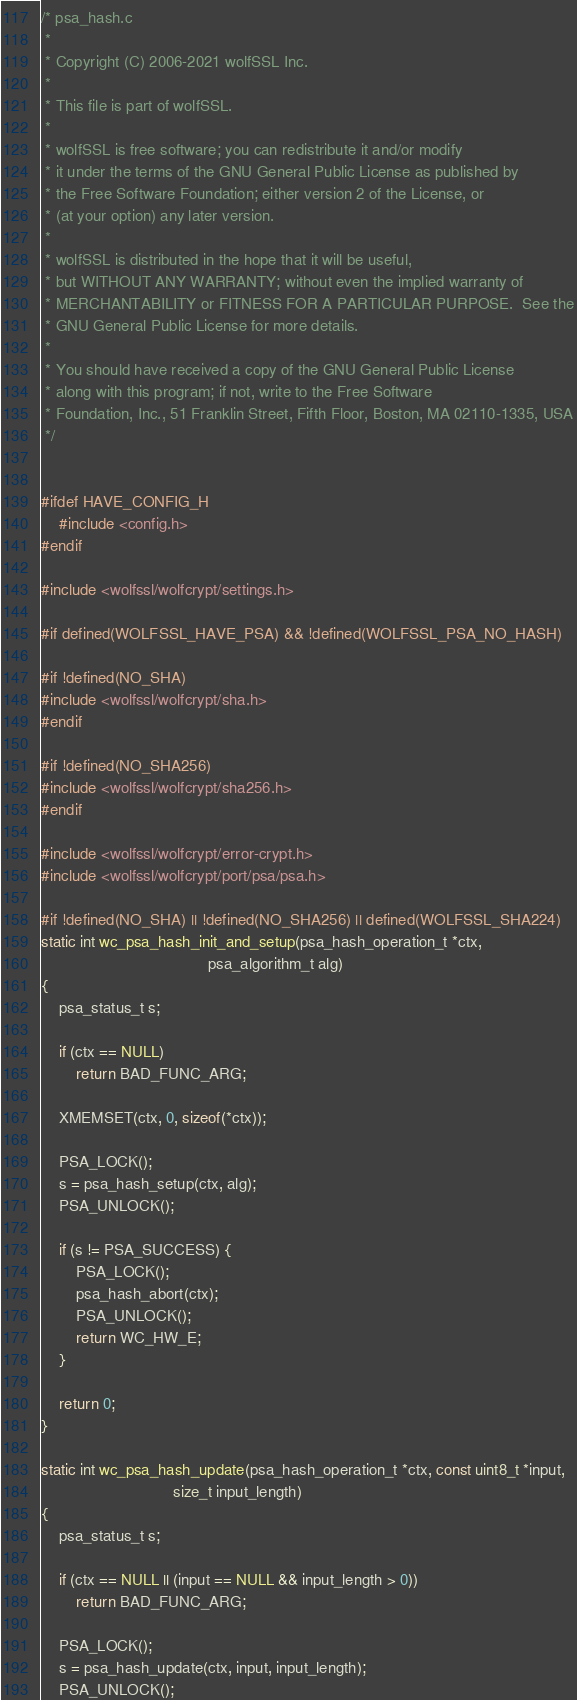Convert code to text. <code><loc_0><loc_0><loc_500><loc_500><_C_>/* psa_hash.c
 *
 * Copyright (C) 2006-2021 wolfSSL Inc.
 *
 * This file is part of wolfSSL.
 *
 * wolfSSL is free software; you can redistribute it and/or modify
 * it under the terms of the GNU General Public License as published by
 * the Free Software Foundation; either version 2 of the License, or
 * (at your option) any later version.
 *
 * wolfSSL is distributed in the hope that it will be useful,
 * but WITHOUT ANY WARRANTY; without even the implied warranty of
 * MERCHANTABILITY or FITNESS FOR A PARTICULAR PURPOSE.  See the
 * GNU General Public License for more details.
 *
 * You should have received a copy of the GNU General Public License
 * along with this program; if not, write to the Free Software
 * Foundation, Inc., 51 Franklin Street, Fifth Floor, Boston, MA 02110-1335, USA
 */


#ifdef HAVE_CONFIG_H
    #include <config.h>
#endif

#include <wolfssl/wolfcrypt/settings.h>

#if defined(WOLFSSL_HAVE_PSA) && !defined(WOLFSSL_PSA_NO_HASH)

#if !defined(NO_SHA)
#include <wolfssl/wolfcrypt/sha.h>
#endif

#if !defined(NO_SHA256)
#include <wolfssl/wolfcrypt/sha256.h>
#endif

#include <wolfssl/wolfcrypt/error-crypt.h>
#include <wolfssl/wolfcrypt/port/psa/psa.h>

#if !defined(NO_SHA) || !defined(NO_SHA256) || defined(WOLFSSL_SHA224)
static int wc_psa_hash_init_and_setup(psa_hash_operation_t *ctx,
                                      psa_algorithm_t alg)
{
    psa_status_t s;

    if (ctx == NULL)
        return BAD_FUNC_ARG;

    XMEMSET(ctx, 0, sizeof(*ctx));

    PSA_LOCK();
    s = psa_hash_setup(ctx, alg);
    PSA_UNLOCK();

    if (s != PSA_SUCCESS) {
        PSA_LOCK();
        psa_hash_abort(ctx);
        PSA_UNLOCK();
        return WC_HW_E;
    }

    return 0;
}

static int wc_psa_hash_update(psa_hash_operation_t *ctx, const uint8_t *input,
                              size_t input_length)
{
    psa_status_t s;

    if (ctx == NULL || (input == NULL && input_length > 0))
        return BAD_FUNC_ARG;

    PSA_LOCK();
    s = psa_hash_update(ctx, input, input_length);
    PSA_UNLOCK();
</code> 